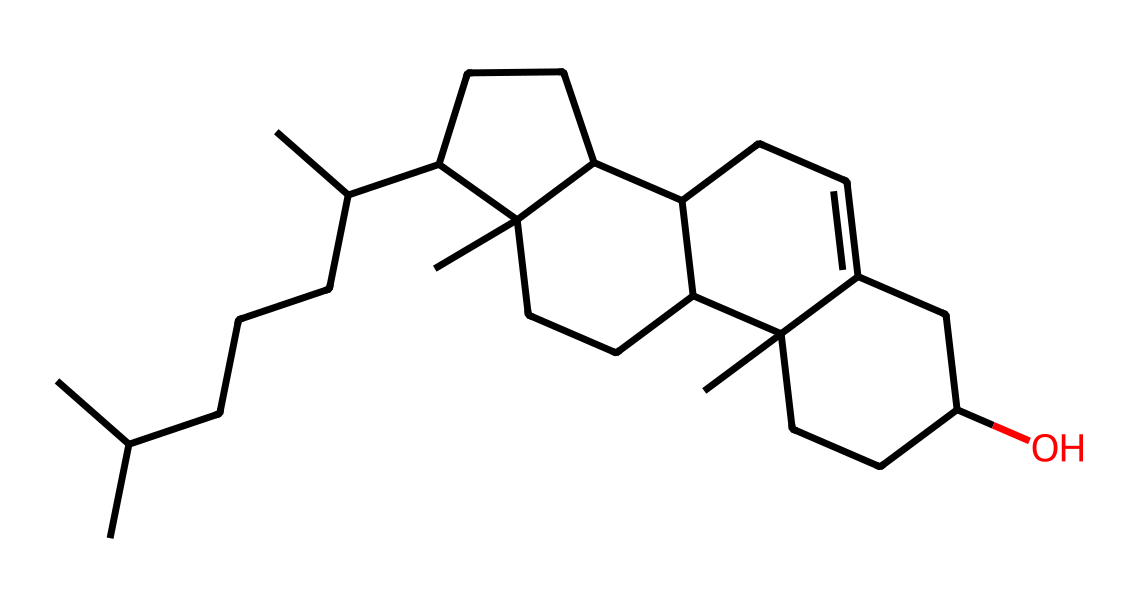What is the primary functional group in this molecule? The primary functional group present in the structure is an alcohol group, indicated by the hydroxyl (-OH) functional group at the end of the chain.
Answer: alcohol How many carbon atoms are there in the molecule? By counting the number of carbon (C) atoms represented in the chemical structure, we find that there are 30 carbon atoms in total.
Answer: 30 What type of lipid is cholesterol categorized as? Cholesterol is categorized as a sterol, which is a subgroup of steroids characterized by a hydroxyl group and a multi-ring structure.
Answer: sterol Does this structure include any double bonds? To determine if there are double bonds, we look for carbon atoms that have fewer than two hydrogens bonded to them; this structure contains a double bond between specific carbon atoms in the ring.
Answer: yes What is the significance of the -OH group in cholesterol? The -OH group is significant because it contributes to the hydrophilic character of cholesterol, allowing it to interact with water-based substances in the body, which affects its functionality in cellular membranes.
Answer: hydrophilic How many rings are present in the cholesterol structure? Upon analyzing the structure, it is noted that there are four fused carbon rings that form the core structure of cholesterol, which is characteristic of sterols.
Answer: four 